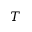<formula> <loc_0><loc_0><loc_500><loc_500>T</formula> 